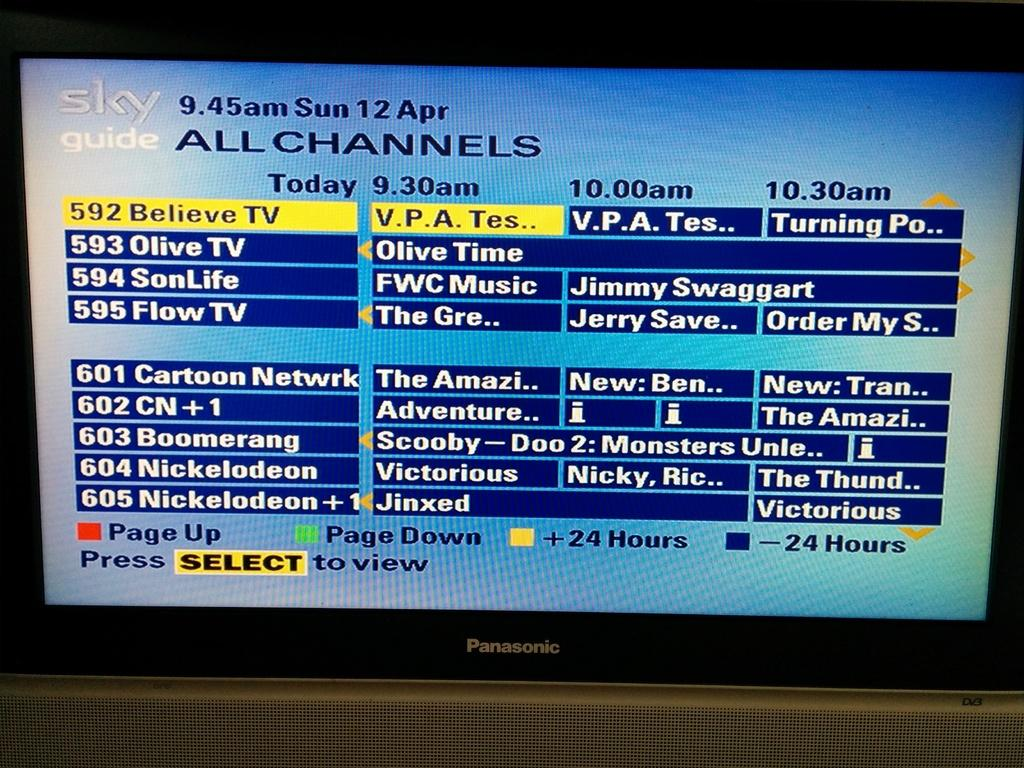<image>
Present a compact description of the photo's key features. Screen showing different channels for Sky Guide television. 